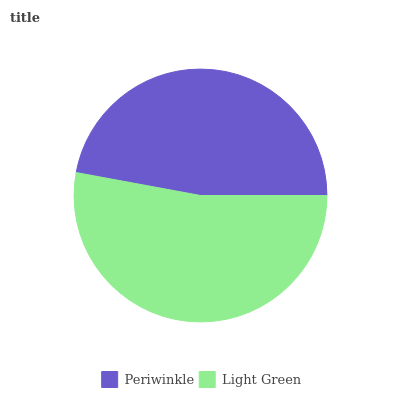Is Periwinkle the minimum?
Answer yes or no. Yes. Is Light Green the maximum?
Answer yes or no. Yes. Is Light Green the minimum?
Answer yes or no. No. Is Light Green greater than Periwinkle?
Answer yes or no. Yes. Is Periwinkle less than Light Green?
Answer yes or no. Yes. Is Periwinkle greater than Light Green?
Answer yes or no. No. Is Light Green less than Periwinkle?
Answer yes or no. No. Is Light Green the high median?
Answer yes or no. Yes. Is Periwinkle the low median?
Answer yes or no. Yes. Is Periwinkle the high median?
Answer yes or no. No. Is Light Green the low median?
Answer yes or no. No. 